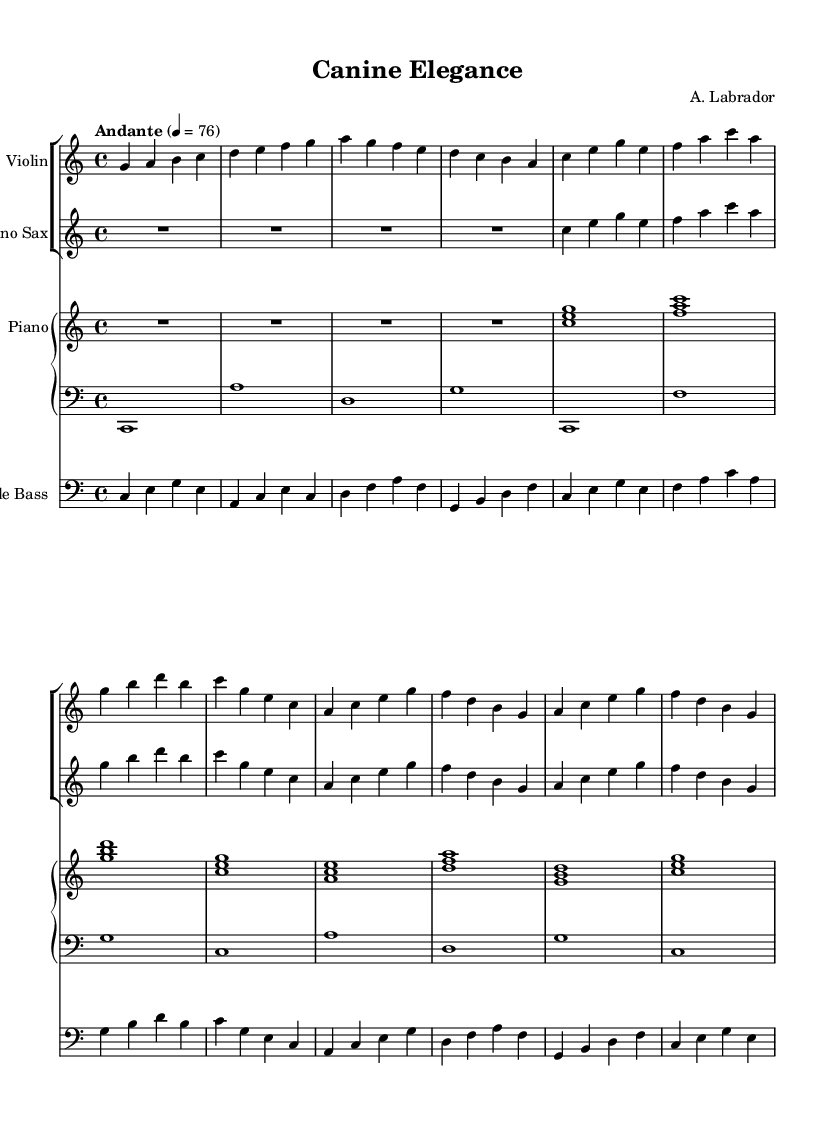What is the key signature of this music? The key signature is C major, which has no sharps or flats.
Answer: C major What is the time signature of this music? The time signature is indicated at the beginning of the piece, which shows that there are four beats in a measure, and the quarter note receives one beat.
Answer: 4/4 What is the tempo marking of this music? The tempo marking, located at the beginning of the score, indicates that the piece should be played at an 'Andante' pace, with a metronome mark of 76 beats per minute.
Answer: Andante How many instruments are featured in this piece? By counting the distinct staves in the score, we can see there are four groups featuring different instruments: Violin, Soprano Sax, Piano, and Double Bass.
Answer: Four Which instrument plays the highest pitch in this piece? Locating the parts in the score, the Violin generally plays the highest pitches compared to the other instruments, appearing in the treble clef without any transpositions.
Answer: Violin What chord type is predominantly used in the piano part? Looking at the chords listed in the piano section, we observe that they primarily consist of major chords built on the root notes (C, F, G, etc.). Therefore, the predominant chord type is major.
Answer: Major How many measures are in the Violin part? By counting the number of bar lines in the Violin staff, we find there are a total of 10 measures present in the piece.
Answer: Ten 